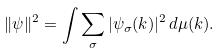Convert formula to latex. <formula><loc_0><loc_0><loc_500><loc_500>\| \psi \| ^ { 2 } = \int \sum _ { \sigma } | \psi _ { \sigma } ( k ) | ^ { 2 } \, d \mu ( k ) .</formula> 